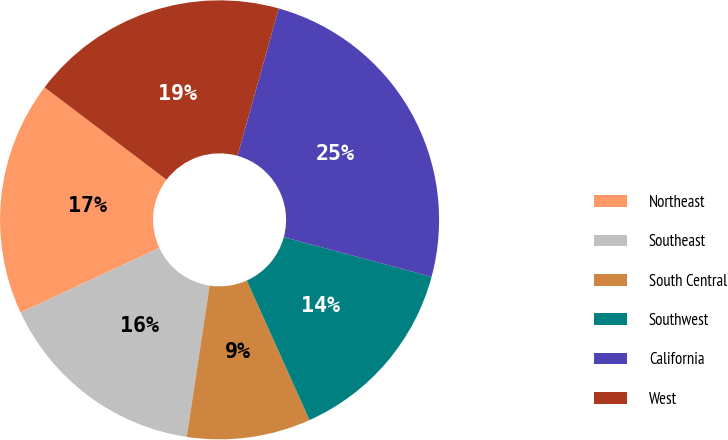Convert chart to OTSL. <chart><loc_0><loc_0><loc_500><loc_500><pie_chart><fcel>Northeast<fcel>Southeast<fcel>South Central<fcel>Southwest<fcel>California<fcel>West<nl><fcel>17.25%<fcel>15.67%<fcel>9.11%<fcel>14.1%<fcel>24.83%<fcel>19.03%<nl></chart> 